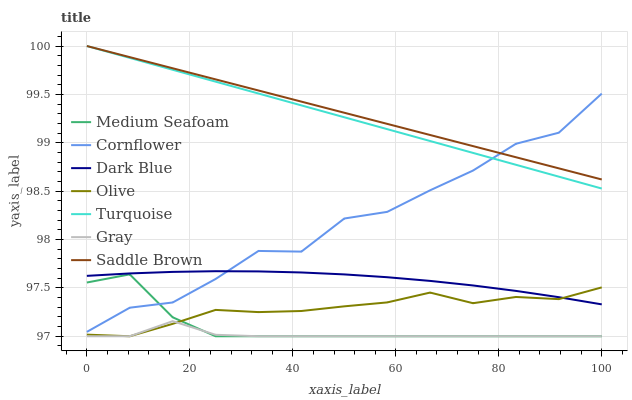Does Gray have the minimum area under the curve?
Answer yes or no. Yes. Does Saddle Brown have the maximum area under the curve?
Answer yes or no. Yes. Does Turquoise have the minimum area under the curve?
Answer yes or no. No. Does Turquoise have the maximum area under the curve?
Answer yes or no. No. Is Turquoise the smoothest?
Answer yes or no. Yes. Is Cornflower the roughest?
Answer yes or no. Yes. Is Gray the smoothest?
Answer yes or no. No. Is Gray the roughest?
Answer yes or no. No. Does Gray have the lowest value?
Answer yes or no. Yes. Does Turquoise have the lowest value?
Answer yes or no. No. Does Saddle Brown have the highest value?
Answer yes or no. Yes. Does Gray have the highest value?
Answer yes or no. No. Is Gray less than Turquoise?
Answer yes or no. Yes. Is Saddle Brown greater than Gray?
Answer yes or no. Yes. Does Olive intersect Medium Seafoam?
Answer yes or no. Yes. Is Olive less than Medium Seafoam?
Answer yes or no. No. Is Olive greater than Medium Seafoam?
Answer yes or no. No. Does Gray intersect Turquoise?
Answer yes or no. No. 